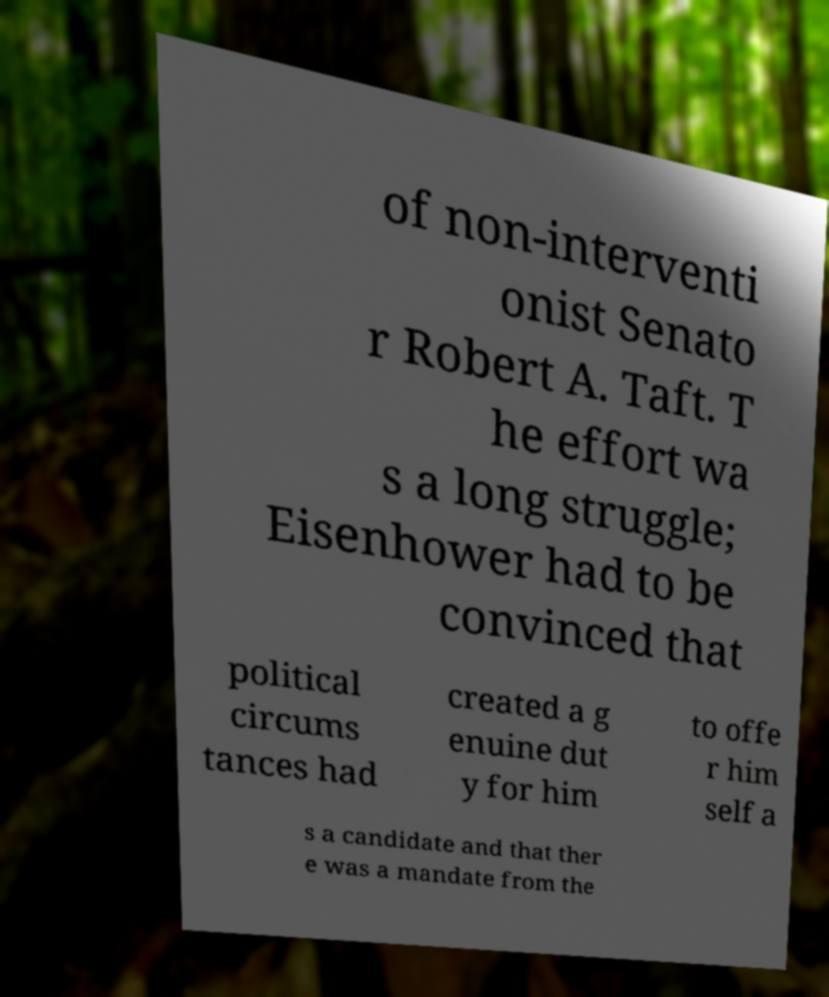For documentation purposes, I need the text within this image transcribed. Could you provide that? of non-interventi onist Senato r Robert A. Taft. T he effort wa s a long struggle; Eisenhower had to be convinced that political circums tances had created a g enuine dut y for him to offe r him self a s a candidate and that ther e was a mandate from the 